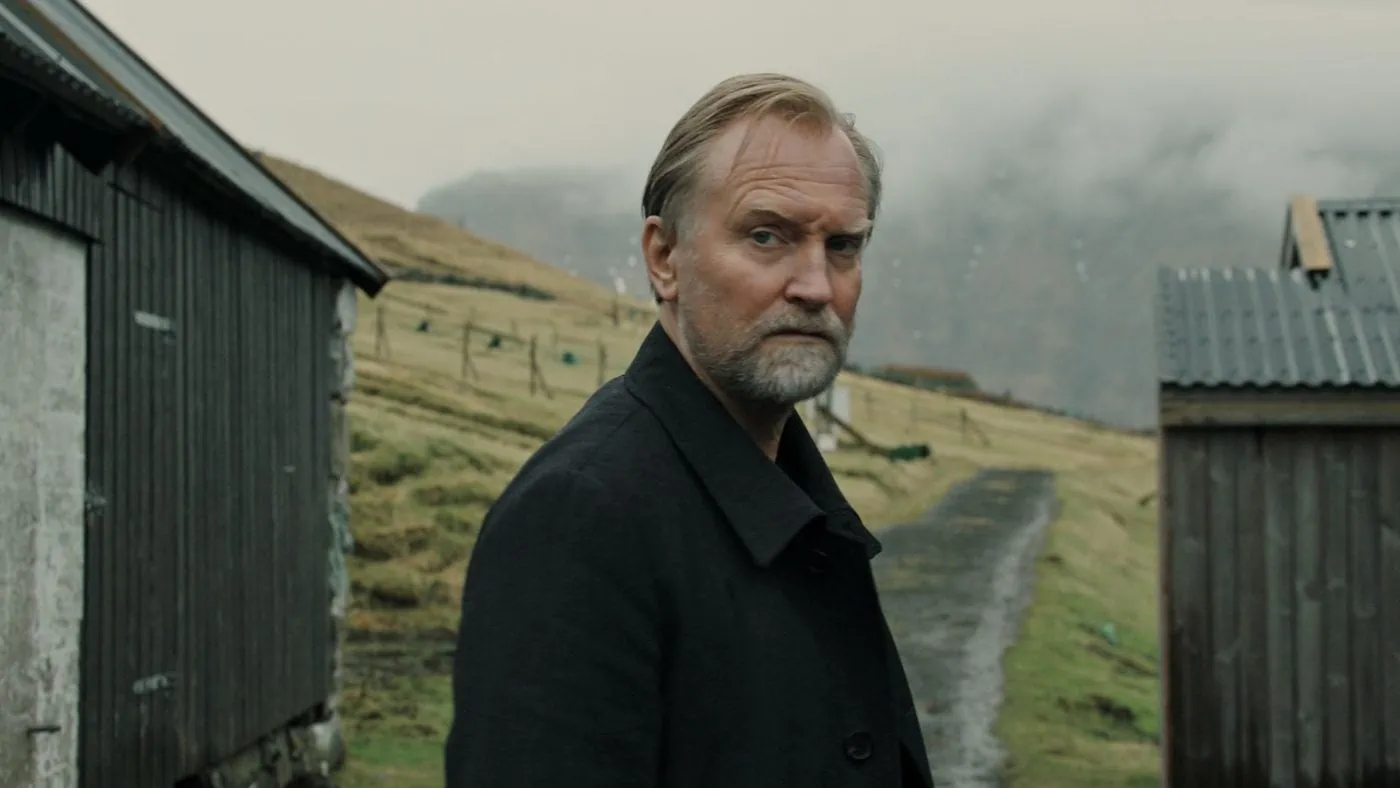Write a short story based on this image. Returning after decades to the place he once called home, Henry stood still, absorbing the familiar yet changed landscape. The old wooden shed, now weathered by years, and the fence he once mended with his father, were like silent specters of his past. The path leading to his childhood retreat was narrower than he remembered, framed by the ghostly outlines of memories. As the clouds above cast a melancholic shadow over the scene, he wondered if revisiting meant reliving joy or reopening wounds. The solitude of the place mirrored his inner turmoil, each sigh of wind carrying echoes of laughter and tears he had long buried. 